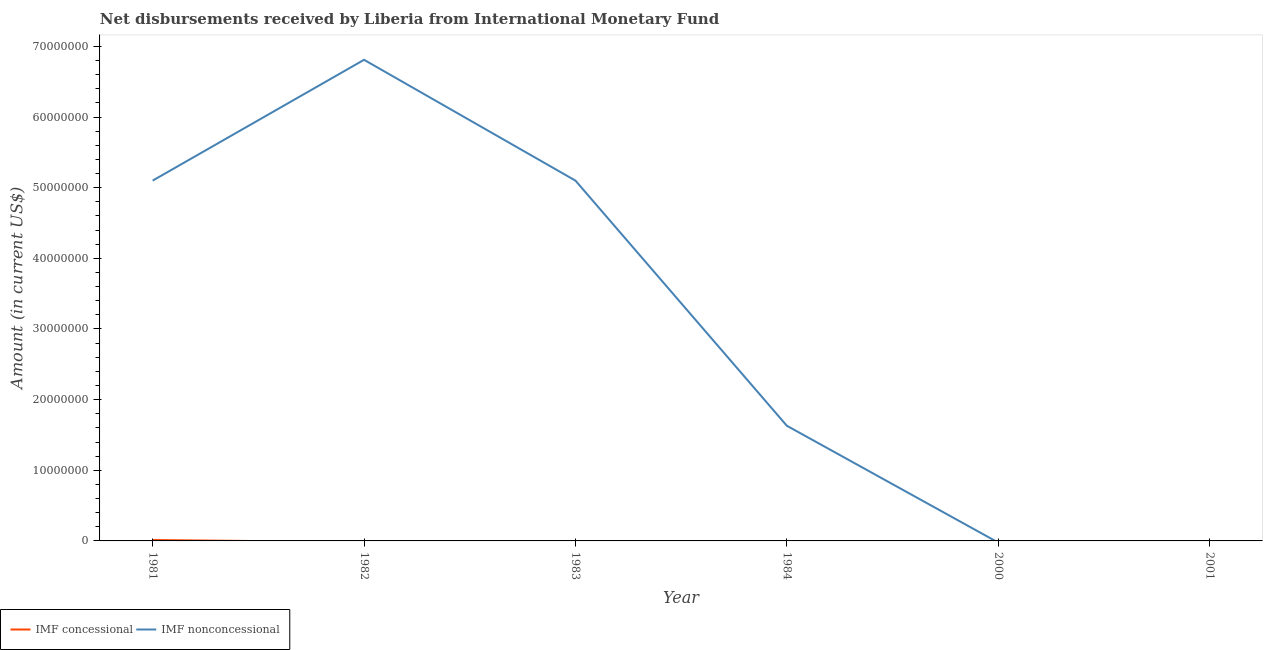What is the net non concessional disbursements from imf in 1982?
Make the answer very short. 6.81e+07. Across all years, what is the maximum net concessional disbursements from imf?
Your response must be concise. 1.29e+05. In which year was the net concessional disbursements from imf maximum?
Your response must be concise. 1981. What is the total net non concessional disbursements from imf in the graph?
Keep it short and to the point. 1.86e+08. What is the difference between the net non concessional disbursements from imf in 1981 and that in 1984?
Your answer should be very brief. 3.47e+07. What is the difference between the net non concessional disbursements from imf in 1983 and the net concessional disbursements from imf in 1982?
Offer a terse response. 5.10e+07. What is the average net concessional disbursements from imf per year?
Provide a short and direct response. 2.15e+04. In the year 1981, what is the difference between the net non concessional disbursements from imf and net concessional disbursements from imf?
Your answer should be very brief. 5.09e+07. In how many years, is the net concessional disbursements from imf greater than 40000000 US$?
Ensure brevity in your answer.  0. What is the ratio of the net non concessional disbursements from imf in 1981 to that in 1982?
Offer a terse response. 0.75. Is the net non concessional disbursements from imf in 1981 less than that in 1984?
Give a very brief answer. No. What is the difference between the highest and the second highest net non concessional disbursements from imf?
Provide a succinct answer. 1.71e+07. What is the difference between the highest and the lowest net non concessional disbursements from imf?
Make the answer very short. 6.81e+07. In how many years, is the net non concessional disbursements from imf greater than the average net non concessional disbursements from imf taken over all years?
Ensure brevity in your answer.  3. Is the net non concessional disbursements from imf strictly less than the net concessional disbursements from imf over the years?
Offer a very short reply. No. How many years are there in the graph?
Your answer should be very brief. 6. Does the graph contain any zero values?
Give a very brief answer. Yes. How are the legend labels stacked?
Provide a succinct answer. Horizontal. What is the title of the graph?
Give a very brief answer. Net disbursements received by Liberia from International Monetary Fund. Does "Under-5(male)" appear as one of the legend labels in the graph?
Provide a short and direct response. No. What is the Amount (in current US$) in IMF concessional in 1981?
Give a very brief answer. 1.29e+05. What is the Amount (in current US$) of IMF nonconcessional in 1981?
Offer a very short reply. 5.10e+07. What is the Amount (in current US$) of IMF nonconcessional in 1982?
Offer a very short reply. 6.81e+07. What is the Amount (in current US$) in IMF nonconcessional in 1983?
Give a very brief answer. 5.10e+07. What is the Amount (in current US$) in IMF concessional in 1984?
Ensure brevity in your answer.  0. What is the Amount (in current US$) in IMF nonconcessional in 1984?
Keep it short and to the point. 1.63e+07. What is the Amount (in current US$) in IMF nonconcessional in 2000?
Your answer should be compact. 0. What is the Amount (in current US$) in IMF concessional in 2001?
Your response must be concise. 0. Across all years, what is the maximum Amount (in current US$) in IMF concessional?
Make the answer very short. 1.29e+05. Across all years, what is the maximum Amount (in current US$) of IMF nonconcessional?
Keep it short and to the point. 6.81e+07. Across all years, what is the minimum Amount (in current US$) of IMF concessional?
Offer a very short reply. 0. Across all years, what is the minimum Amount (in current US$) in IMF nonconcessional?
Ensure brevity in your answer.  0. What is the total Amount (in current US$) of IMF concessional in the graph?
Offer a very short reply. 1.29e+05. What is the total Amount (in current US$) in IMF nonconcessional in the graph?
Provide a succinct answer. 1.86e+08. What is the difference between the Amount (in current US$) of IMF nonconcessional in 1981 and that in 1982?
Give a very brief answer. -1.71e+07. What is the difference between the Amount (in current US$) in IMF nonconcessional in 1981 and that in 1983?
Provide a short and direct response. 0. What is the difference between the Amount (in current US$) in IMF nonconcessional in 1981 and that in 1984?
Ensure brevity in your answer.  3.47e+07. What is the difference between the Amount (in current US$) of IMF nonconcessional in 1982 and that in 1983?
Your answer should be compact. 1.71e+07. What is the difference between the Amount (in current US$) of IMF nonconcessional in 1982 and that in 1984?
Your answer should be compact. 5.18e+07. What is the difference between the Amount (in current US$) in IMF nonconcessional in 1983 and that in 1984?
Provide a short and direct response. 3.47e+07. What is the difference between the Amount (in current US$) in IMF concessional in 1981 and the Amount (in current US$) in IMF nonconcessional in 1982?
Keep it short and to the point. -6.80e+07. What is the difference between the Amount (in current US$) in IMF concessional in 1981 and the Amount (in current US$) in IMF nonconcessional in 1983?
Keep it short and to the point. -5.09e+07. What is the difference between the Amount (in current US$) of IMF concessional in 1981 and the Amount (in current US$) of IMF nonconcessional in 1984?
Your answer should be very brief. -1.62e+07. What is the average Amount (in current US$) of IMF concessional per year?
Provide a short and direct response. 2.15e+04. What is the average Amount (in current US$) of IMF nonconcessional per year?
Keep it short and to the point. 3.11e+07. In the year 1981, what is the difference between the Amount (in current US$) of IMF concessional and Amount (in current US$) of IMF nonconcessional?
Your response must be concise. -5.09e+07. What is the ratio of the Amount (in current US$) of IMF nonconcessional in 1981 to that in 1982?
Your answer should be very brief. 0.75. What is the ratio of the Amount (in current US$) in IMF nonconcessional in 1981 to that in 1984?
Offer a terse response. 3.13. What is the ratio of the Amount (in current US$) in IMF nonconcessional in 1982 to that in 1983?
Your response must be concise. 1.34. What is the ratio of the Amount (in current US$) of IMF nonconcessional in 1982 to that in 1984?
Give a very brief answer. 4.18. What is the ratio of the Amount (in current US$) of IMF nonconcessional in 1983 to that in 1984?
Provide a short and direct response. 3.13. What is the difference between the highest and the second highest Amount (in current US$) in IMF nonconcessional?
Your answer should be very brief. 1.71e+07. What is the difference between the highest and the lowest Amount (in current US$) in IMF concessional?
Make the answer very short. 1.29e+05. What is the difference between the highest and the lowest Amount (in current US$) of IMF nonconcessional?
Keep it short and to the point. 6.81e+07. 